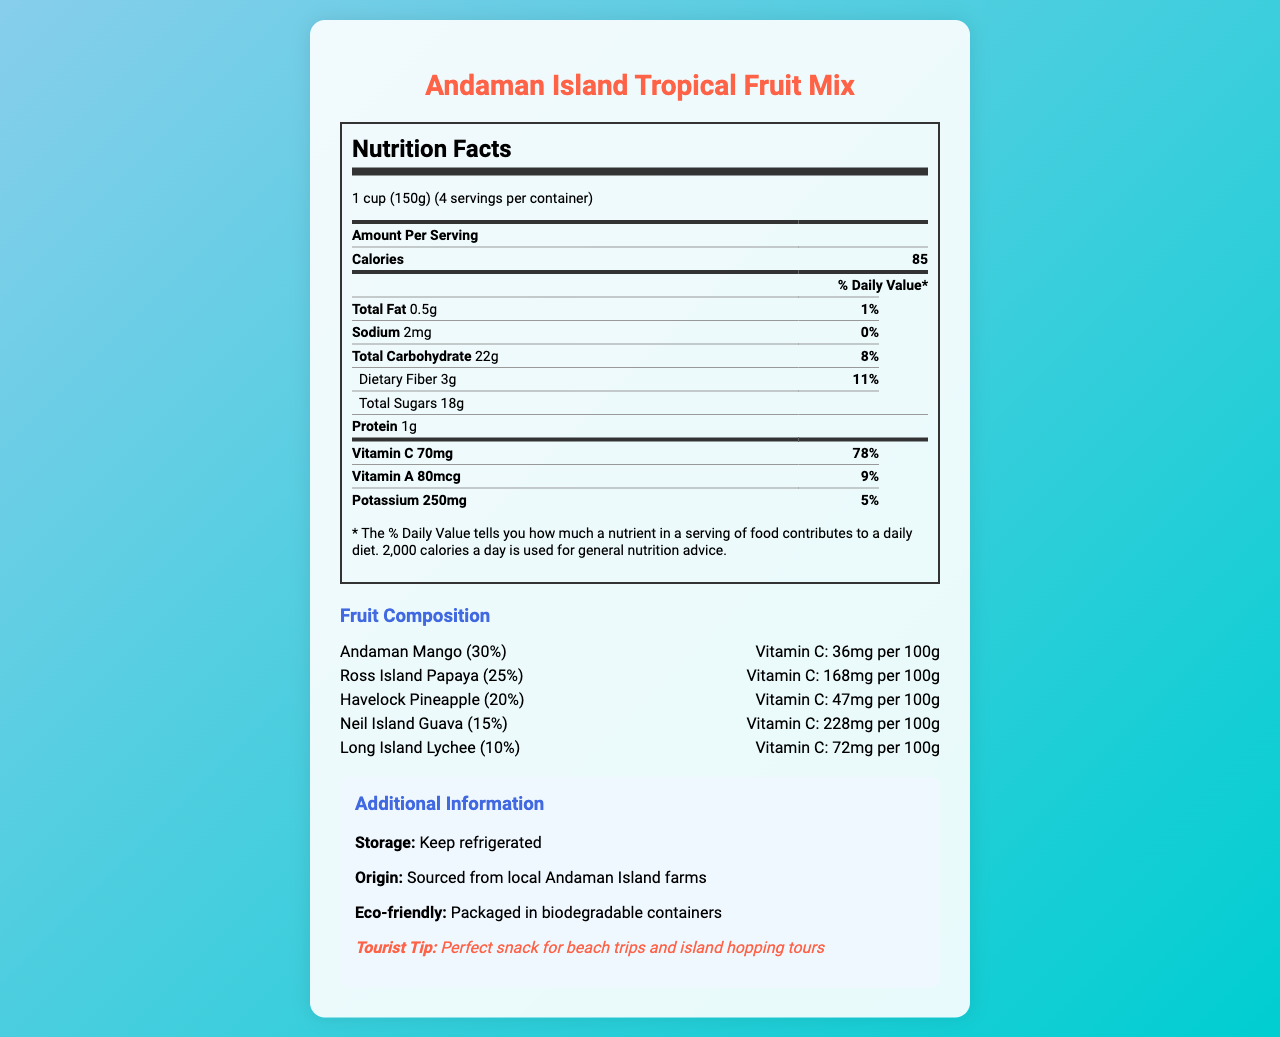what is the serving size of the Andaman Island Tropical Fruit Mix? The serving size is mentioned at the beginning of the nutrition facts section as "1 cup (150g)".
Answer: 1 cup (150g) how many calories are in one serving of the fruit mix? The nutrition facts section lists calories per serving as 85.
Answer: 85 how much vitamin C is in one serving, and what percentage of the daily value does this represent? The nutrition facts show that one serving contains 70mg of vitamin C, which is 78% of the daily value.
Answer: 70mg, 78% list the fruits comprising the Andaman Island Tropical Fruit Mix. The fruit composition section lists these fruits as part of the mix.
Answer: Andaman Mango, Ross Island Papaya, Havelock Pineapple, Neil Island Guava, Long Island Lychee what is the percentage of Neil Island Guava in the mix? Under the fruit composition section, it shows Neil Island Guava makes up 15% of the mix.
Answer: 15% which fruit has the highest vitamin C content per 100g? A. Andaman Mango B. Ross Island Papaya C. Havelock Pineapple D. Neil Island Guava According to the fruit composition section, Neil Island Guava has the highest vitamin C content per 100g at 228mg.
Answer: D. Neil Island Guava how much dietary fiber does one serving of the fruit mix contain? A. 1g B. 2g C. 3g D. 4g The dietary fiber content is listed as 3g per serving in the nutrition facts section.
Answer: C. 3g is the sodium content in one serving significant? The sodium content is only 2mg per serving, which represents 0% of the daily value, indicating it is not significant.
Answer: No is the packaging of the Andaman Island Tropical Fruit Mix eco-friendly? The additional information section states that the product is packaged in biodegradable containers.
Answer: Yes can we determine the exact farm each fruit is sourced from? The document only states that the fruits are sourced from local Andaman Island farms without specifying exact farms.
Answer: Cannot be determined summarize the main idea of the document of the Andaman Island Tropical Fruit Mix. The document combines nutrition facts, fruit composition, and additional information, giving a comprehensive understanding of the product's health benefits and usage tips.
Answer: The document provides a detailed overview of the nutritional content of the Andaman Island Tropical Fruit Mix, highlighting key nutritional values including vitamin C content. It also describes the composition of the mix, origin, and eco-friendly packaging, making it suitable for tourists in the Andaman Islands. 